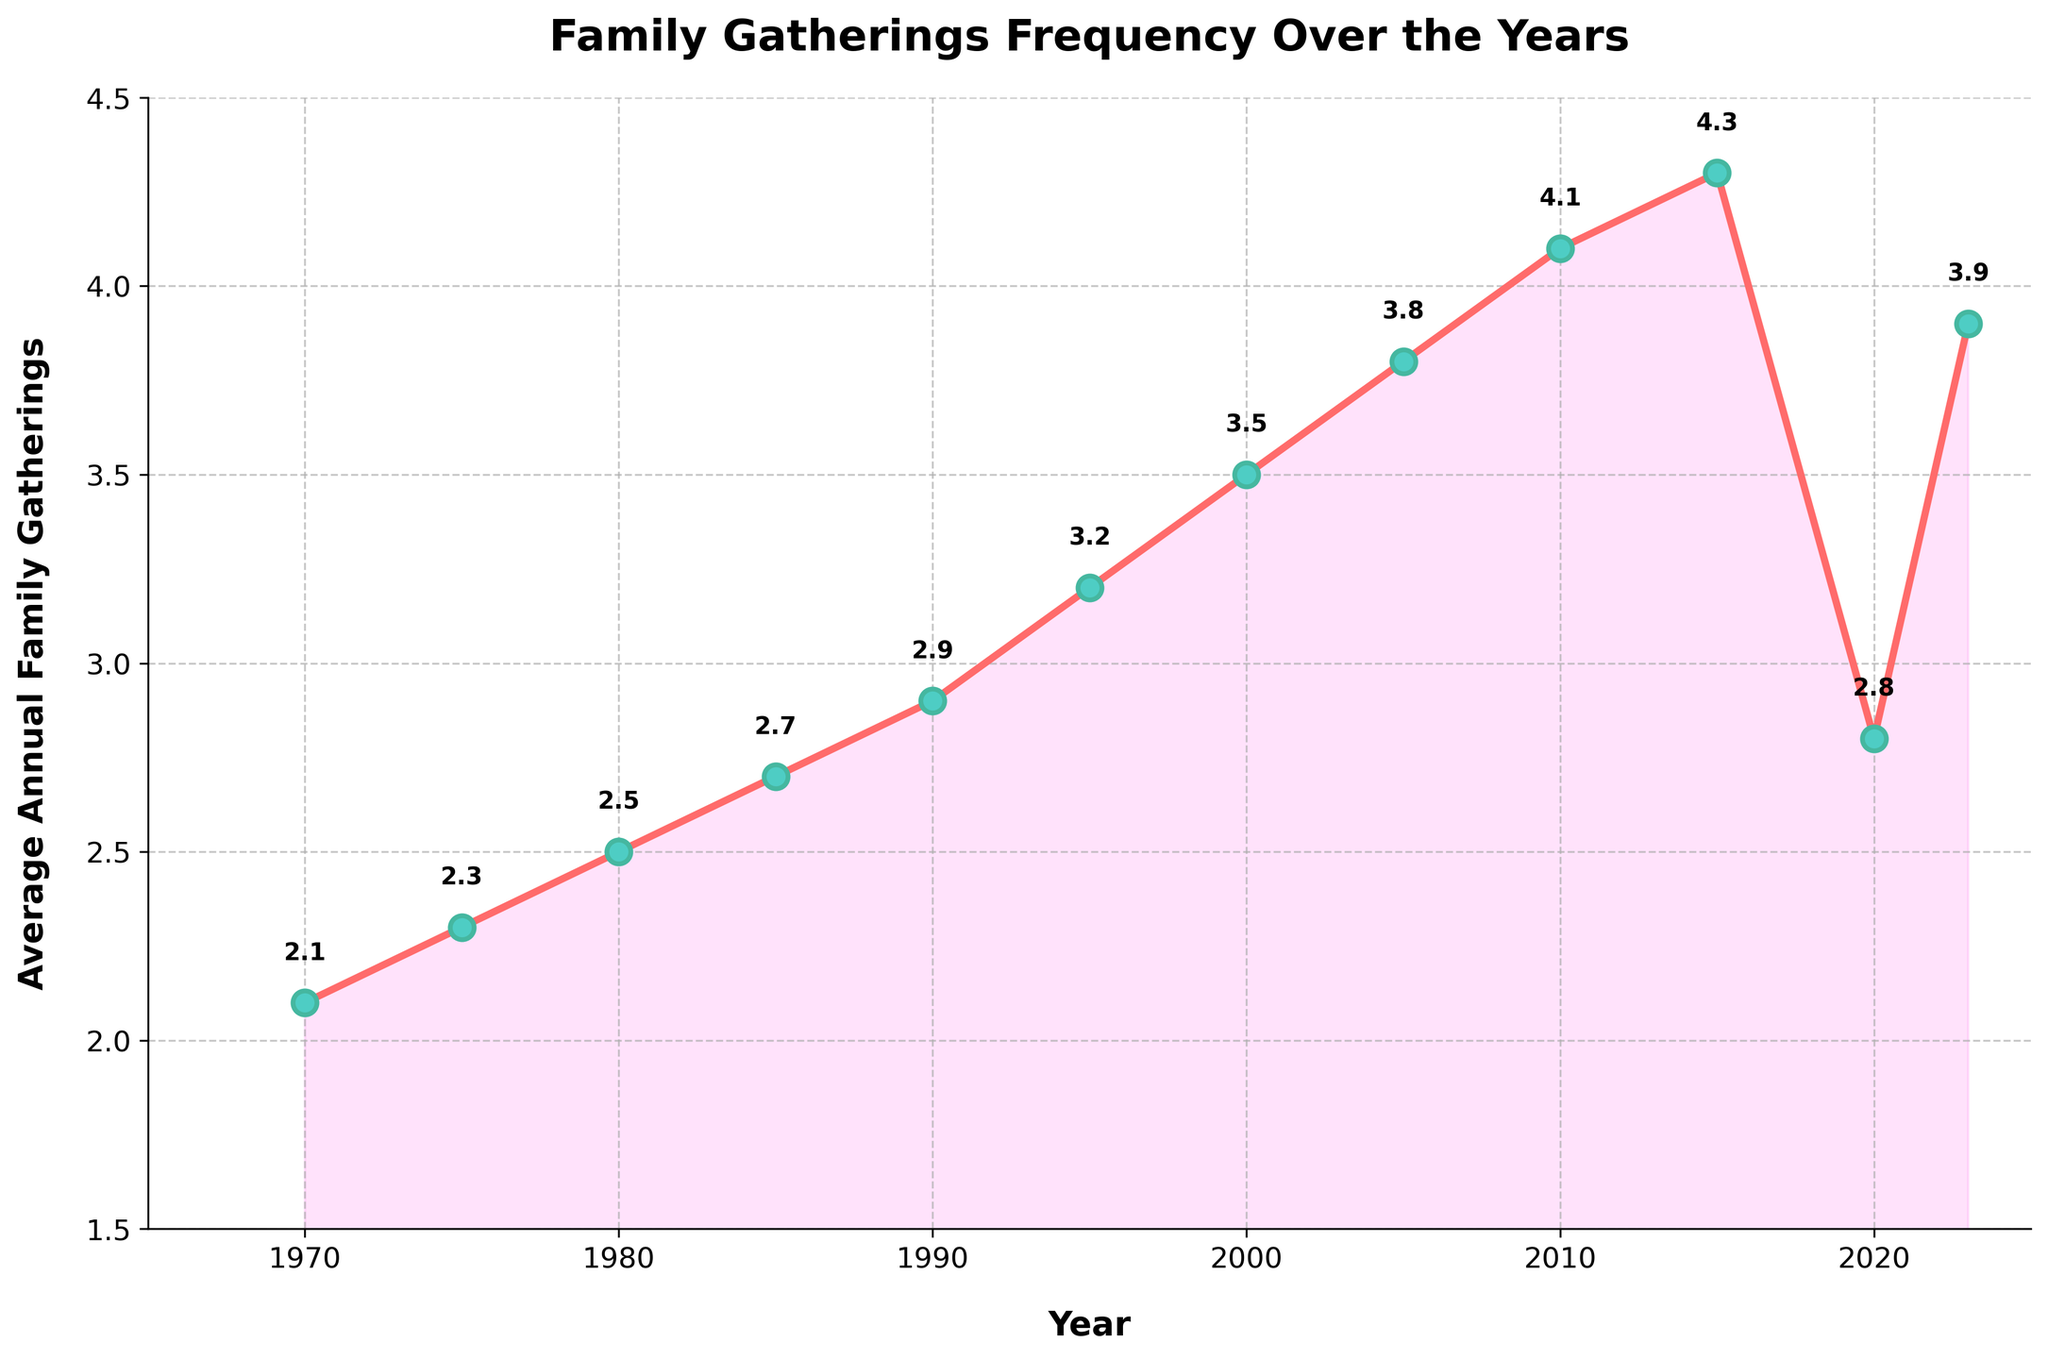When did the average annual family gatherings peak before 2023? By looking at the figure, find the highest point in the graph before 2023. The highest peak appears in 2015 with an average of 4.3 gatherings per year.
Answer: 2015 How did the frequency of gatherings change from 2020 to 2023? Compare the data points for these two years. In 2020, the frequency was 2.8, and in 2023 it increased to 3.9. Calculate the difference as 3.9 - 2.8.
Answer: Increase by 1.1 Which year experienced a significant drop in gatherings compared to the previous year? Look for the steepest decline in the line plot. The drop occurs between 2015 and 2020, where gatherings fell from 4.3 to 2.8.
Answer: 2020 What's the average number of annual gatherings from 1980 to 2000? Sum the values from 1980 to 2000 (2.5, 2.7, 2.9, 3.2, 3.5) and divide by the number of years (5). Calculations: (2.5 + 2.7 + 2.9 + 3.2 + 3.5)/5 = 14.8/5.
Answer: 2.96 How does the frequency of gatherings in 1970 compare with 2023? Compare the points for 1970 (2.1) and 2023 (3.9). Note that 3.9 is higher than 2.1.
Answer: Higher in 2023 Which two consecutive years had the smallest change in family gatherings? Find the smallest difference between consecutive years. The differences are: 1970-1975 (0.2), 1975-1980 (0.2), 1980-1985 (0.2), 1985-1990 (0.2), 1990-1995 (0.3), 1995-2000 (0.3), 2000-2005 (0.3), 2005-2010 (0.3), 2010-2015 (0.2), 2015-2020 (1.5), 2020-2023 (1.1). The smallest changes are 0.2 for 1970-1975, 1975-1980, 1980-1985, 1985-1990, and 2010-2015.
Answer: 1970-1975, 1975-1980, 1980-1985, 1985-1990, 2010-2015 Why is 2020 a notable year in the plot? 2020 shows a dramatic drop from the previous year, which is visually evident from the steep decline in the line plot. This indicates a significant decrease in family gatherings.
Answer: Significant drop What is the range of average annual family gatherings over the years? Identify the highest and lowest points on the graph. The highest value is 4.3 in 2015, and the lowest is 2.1 in 1970. Calculate the range by subtracting the lowest value from the highest.
Answer: 2.2 Did the number of family gatherings ever return to the peak of 2015 after the drop in 2020? Compare the peak value in 2015 with the following years. In 2015, it peaked at 4.3, but subsequent values (2020: 2.8, 2023: 3.9) did not return to 4.3.
Answer: No Determine the overall trend in family gatherings from 1970 to 2023. Observe the general direction of the line, which shows an upward trend from 1970 (2.1) to 2015 (4.3). Despite a drop in 2020, there's a recovery by 2023 (3.9).
Answer: Upward trend 